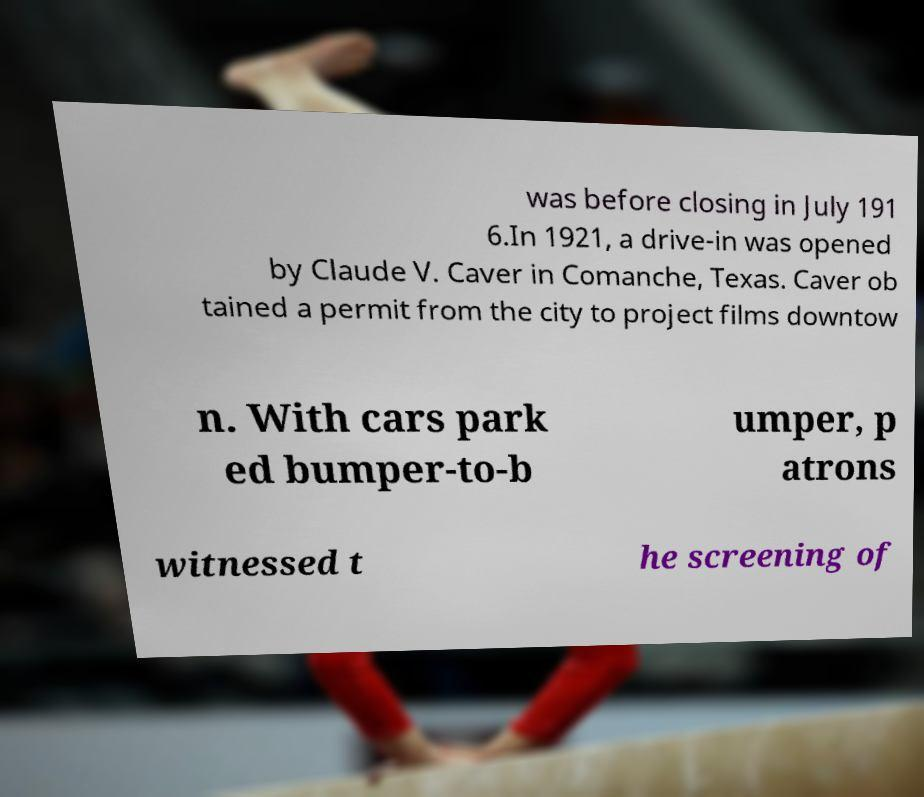Could you extract and type out the text from this image? was before closing in July 191 6.In 1921, a drive-in was opened by Claude V. Caver in Comanche, Texas. Caver ob tained a permit from the city to project films downtow n. With cars park ed bumper-to-b umper, p atrons witnessed t he screening of 